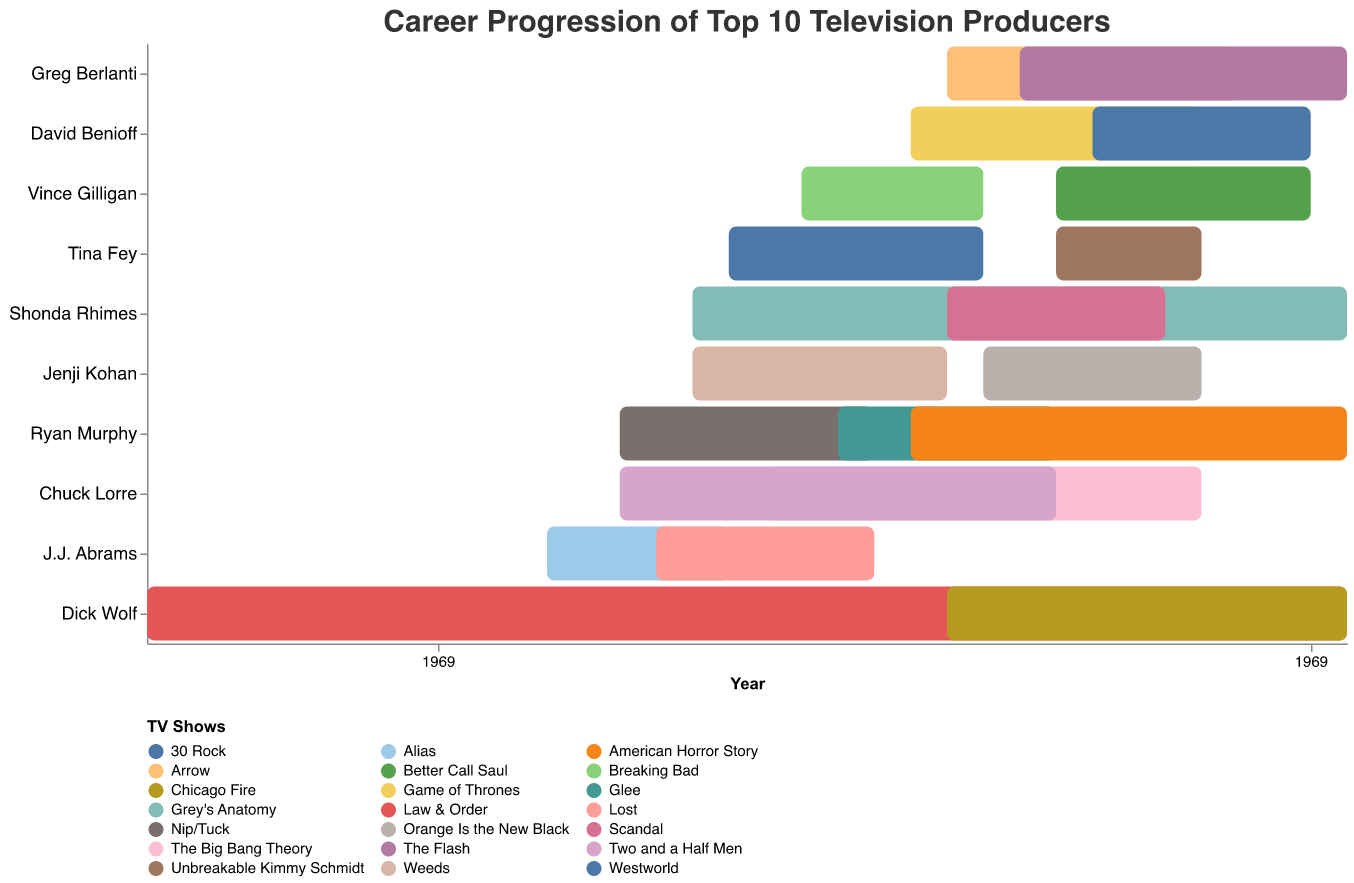Who has the longest ongoing project according to the chart? Shonda Rhimes has been producing Grey's Anatomy from 2005 to 2023, and it is still ongoing.
Answer: Shonda Rhimes What two projects did Tina Fey produce and during what time periods? Tina Fey produced 30 Rock from 2006 to 2013 and Unbreakable Kimmy Schmidt from 2015 to 2019.
Answer: 30 Rock (2006-2013) and Unbreakable Kimmy Schmidt (2015-2019) Which producer worked on multiple projects that overlap in time? Ryan Murphy worked on Nip/Tuck from 2003 to 2010, Glee from 2009 to 2015, and American Horror Story from 2011 to 2023. All these periods have some overlaps.
Answer: Ryan Murphy During which years were the most projects running concurrently? In 2015, there were several ongoing projects: Scandal, Grey's Anatomy, American Horror Story, Chicago Fire, Arrow, The Flash, 30 Rock, Unbreakable Kimmy Schmidt, Game of Thrones, Westworld, Better Call Saul, and Orange Is the New Black.
Answer: 2015 Who started their first major project the earliest, and what was the project? Dick Wolf started his first major project, Law & Order, in 1990.
Answer: Dick Wolf with Law & Order Which producer has worked continuously without any break according to the chart? Shonda Rhimes produced Grey's Anatomy from 2005 to 2023 and Scandal from 2012 to 2018 without any break between projects.
Answer: Shonda Rhimes Which two producers have projects ending in 2023? Shonda Rhimes with Grey's Anatomy, Ryan Murphy with American Horror Story, and Greg Berlanti with The Flash all have projects that are ongoing and end in 2023.
Answer: Shonda Rhimes, Ryan Murphy, and Greg Berlanti Between Shonda Rhimes and Dick Wolf, who has had more projects ongoing at the same time? Shonda Rhimes had two projects overlapping from 2012 to 2018 (Grey's Anatomy and Scandal), while Dick Wolf had Law & Order from 1990 to 2023 and Chicago Fire from 2012 to 2023, which means Dick Wolf had two overlapping projects for a longer period.
Answer: Dick Wolf What are the durations of Vince Gilligan's projects, and which one was longer? Vince Gilligan's Breaking Bad ran from 2008 to 2013 (5 years), and Better Call Saul ran from 2015 to 2022 (7 years). Better Call Saul was the longer project.
Answer: Better Call Saul (7 years) Name a producer whose two projects had no overlap at all. Jenji Kohan's projects Weeds (2005-2012) and Orange Is the New Black (2013-2019) did not overlap.
Answer: Jenji Kohan 